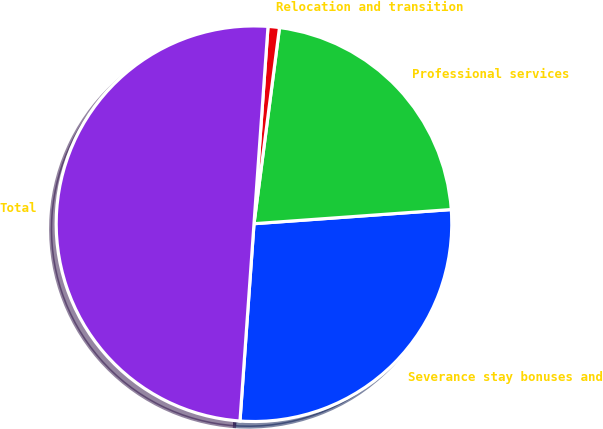<chart> <loc_0><loc_0><loc_500><loc_500><pie_chart><fcel>Severance stay bonuses and<fcel>Professional services<fcel>Relocation and transition<fcel>Total<nl><fcel>27.27%<fcel>21.8%<fcel>0.93%<fcel>50.0%<nl></chart> 